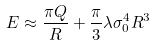Convert formula to latex. <formula><loc_0><loc_0><loc_500><loc_500>E \approx { \frac { \pi Q } { R } } + { \frac { \pi } { 3 } } \lambda \sigma _ { 0 } ^ { 4 } R ^ { 3 }</formula> 